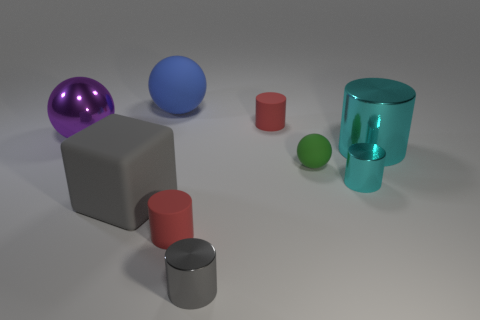Is there any other thing that has the same shape as the big gray thing?
Provide a short and direct response. No. There is a ball right of the blue rubber sphere; how many cyan things are in front of it?
Offer a terse response. 1. Is there a metallic cylinder of the same color as the large cube?
Provide a succinct answer. Yes. Is the size of the gray block the same as the blue object?
Your response must be concise. Yes. What is the material of the tiny gray thing in front of the cyan cylinder behind the green object?
Keep it short and to the point. Metal. There is a big blue thing that is the same shape as the purple object; what is it made of?
Your response must be concise. Rubber. There is a red object in front of the block; is its size the same as the gray metal cylinder?
Your answer should be compact. Yes. How many rubber objects are tiny gray things or large spheres?
Give a very brief answer. 1. There is a ball that is left of the small gray metallic thing and in front of the blue matte object; what material is it?
Give a very brief answer. Metal. Is the tiny green sphere made of the same material as the block?
Offer a very short reply. Yes. 